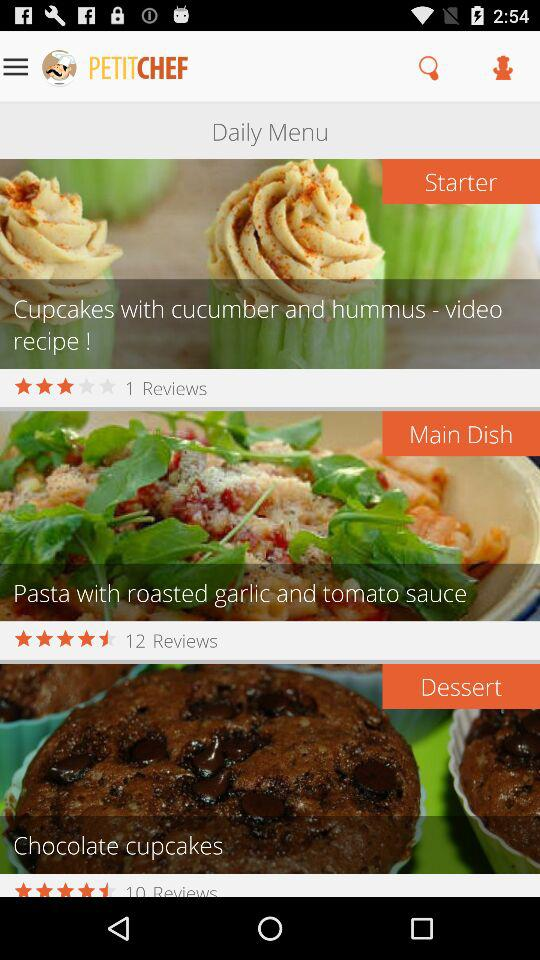What is the name of the application? The name of the application is "PETITCHEF". 